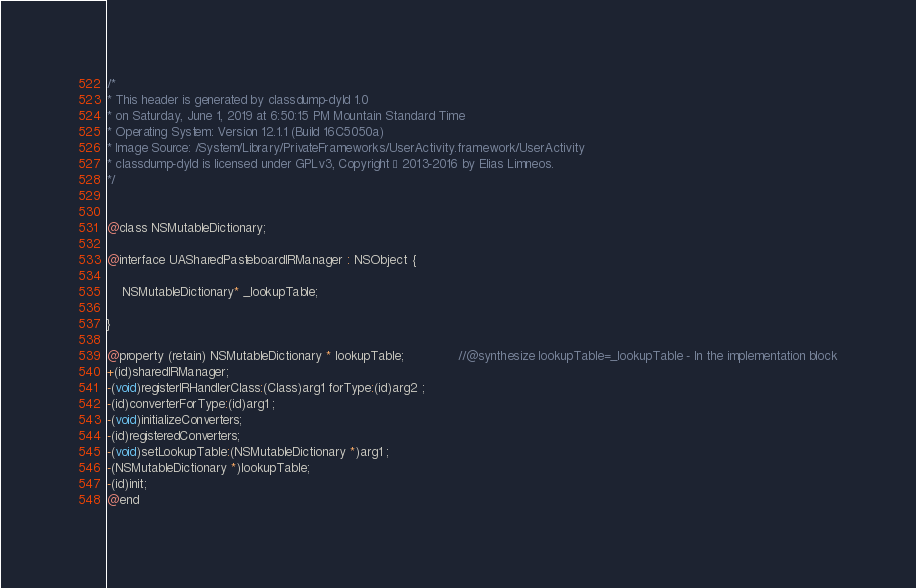<code> <loc_0><loc_0><loc_500><loc_500><_C_>/*
* This header is generated by classdump-dyld 1.0
* on Saturday, June 1, 2019 at 6:50:15 PM Mountain Standard Time
* Operating System: Version 12.1.1 (Build 16C5050a)
* Image Source: /System/Library/PrivateFrameworks/UserActivity.framework/UserActivity
* classdump-dyld is licensed under GPLv3, Copyright © 2013-2016 by Elias Limneos.
*/


@class NSMutableDictionary;

@interface UASharedPasteboardIRManager : NSObject {

	NSMutableDictionary* _lookupTable;

}

@property (retain) NSMutableDictionary * lookupTable;              //@synthesize lookupTable=_lookupTable - In the implementation block
+(id)sharedIRManager;
-(void)registerIRHandlerClass:(Class)arg1 forType:(id)arg2 ;
-(id)converterForType:(id)arg1 ;
-(void)initializeConverters;
-(id)registeredConverters;
-(void)setLookupTable:(NSMutableDictionary *)arg1 ;
-(NSMutableDictionary *)lookupTable;
-(id)init;
@end

</code> 